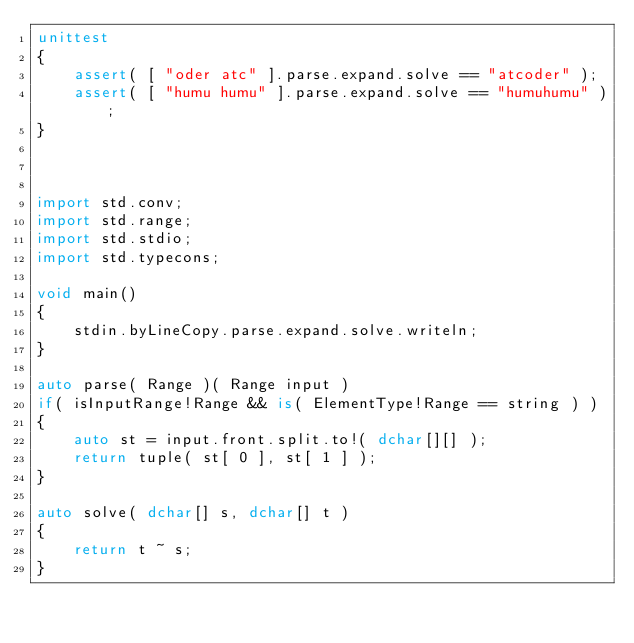<code> <loc_0><loc_0><loc_500><loc_500><_D_>unittest
{
	assert( [ "oder atc" ].parse.expand.solve == "atcoder" );
	assert( [ "humu humu" ].parse.expand.solve == "humuhumu" );
}



import std.conv;
import std.range;
import std.stdio;
import std.typecons;

void main()
{
	stdin.byLineCopy.parse.expand.solve.writeln;
}

auto parse( Range )( Range input )
if( isInputRange!Range && is( ElementType!Range == string ) )
{
	auto st = input.front.split.to!( dchar[][] );
	return tuple( st[ 0 ], st[ 1 ] );
}

auto solve( dchar[] s, dchar[] t )
{
	return t ~ s;
}
</code> 